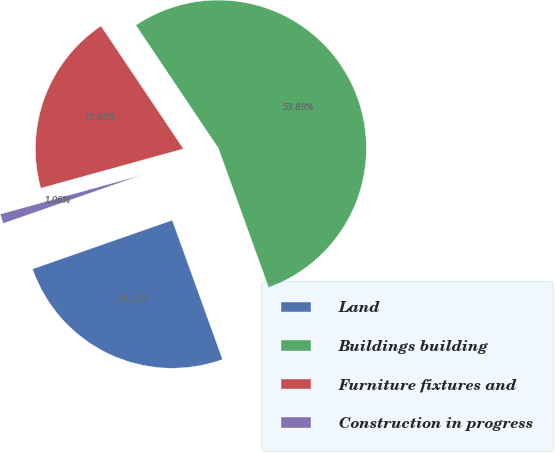<chart> <loc_0><loc_0><loc_500><loc_500><pie_chart><fcel>Land<fcel>Buildings building<fcel>Furniture fixtures and<fcel>Construction in progress<nl><fcel>25.17%<fcel>53.89%<fcel>19.88%<fcel>1.06%<nl></chart> 